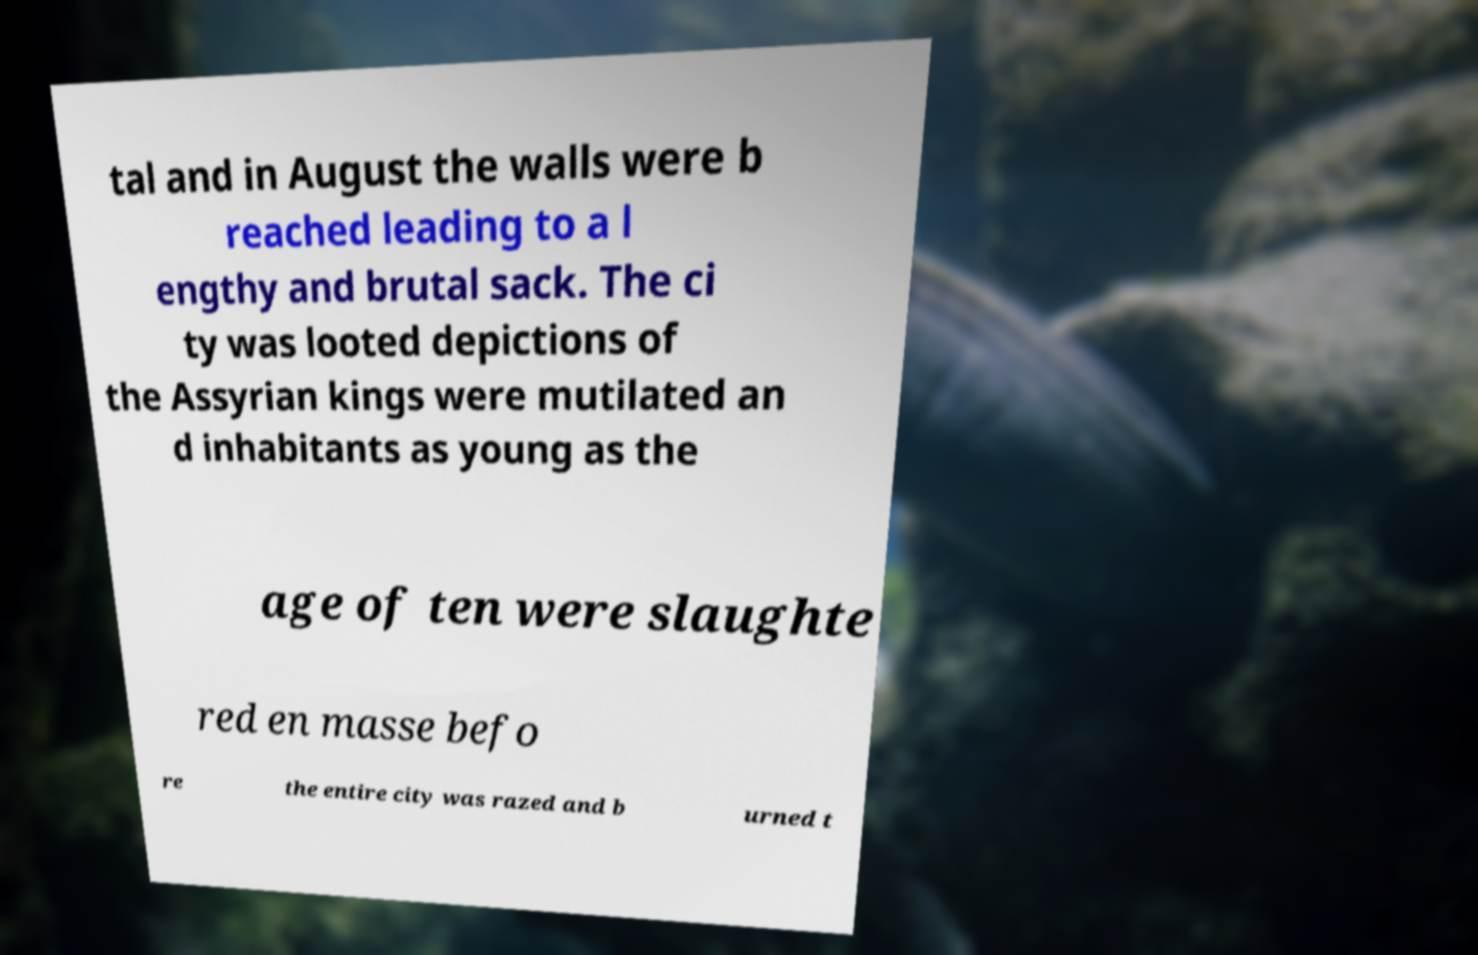What messages or text are displayed in this image? I need them in a readable, typed format. tal and in August the walls were b reached leading to a l engthy and brutal sack. The ci ty was looted depictions of the Assyrian kings were mutilated an d inhabitants as young as the age of ten were slaughte red en masse befo re the entire city was razed and b urned t 